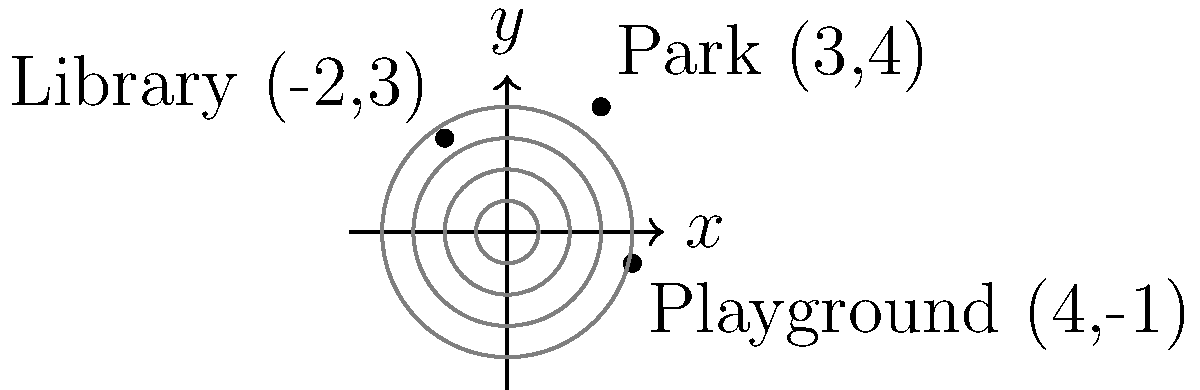As a mother encouraging outdoor activities, you want to represent locations in polar coordinates. Given the Cartesian coordinates of three locations: Park (3,4), Library (-2,3), and Playground (4,-1), which location has the smallest polar angle $\theta$ when converted to polar coordinates $(r,\theta)$? To solve this problem, we need to convert each location from Cartesian coordinates (x,y) to polar coordinates (r,θ). The formulas for conversion are:

$r = \sqrt{x^2 + y^2}$
$\theta = \tan^{-1}(\frac{y}{x})$

However, we need to be careful with the arctangent function and adjust the angle based on the quadrant. Let's convert each location:

1. Park (3,4):
   $r = \sqrt{3^2 + 4^2} = 5$
   $\theta = \tan^{-1}(\frac{4}{3}) \approx 0.927$ radians or 53.13°

2. Library (-2,3):
   $r = \sqrt{(-2)^2 + 3^2} = \sqrt{13}$
   $\theta = \tan^{-1}(\frac{3}{-2}) + \pi \approx 2.158$ radians or 123.69°
   (We add π because it's in the 2nd quadrant)

3. Playground (4,-1):
   $r = \sqrt{4^2 + (-1)^2} = \sqrt{17}$
   $\theta = \tan^{-1}(\frac{-1}{4}) \approx -0.245$ radians or -14.04°
   (This is already in the correct quadrant)

Comparing the angles:
Playground: -14.04°
Park: 53.13°
Library: 123.69°

The smallest angle is -14.04°, which corresponds to the Playground.
Answer: Playground (4,-1) 